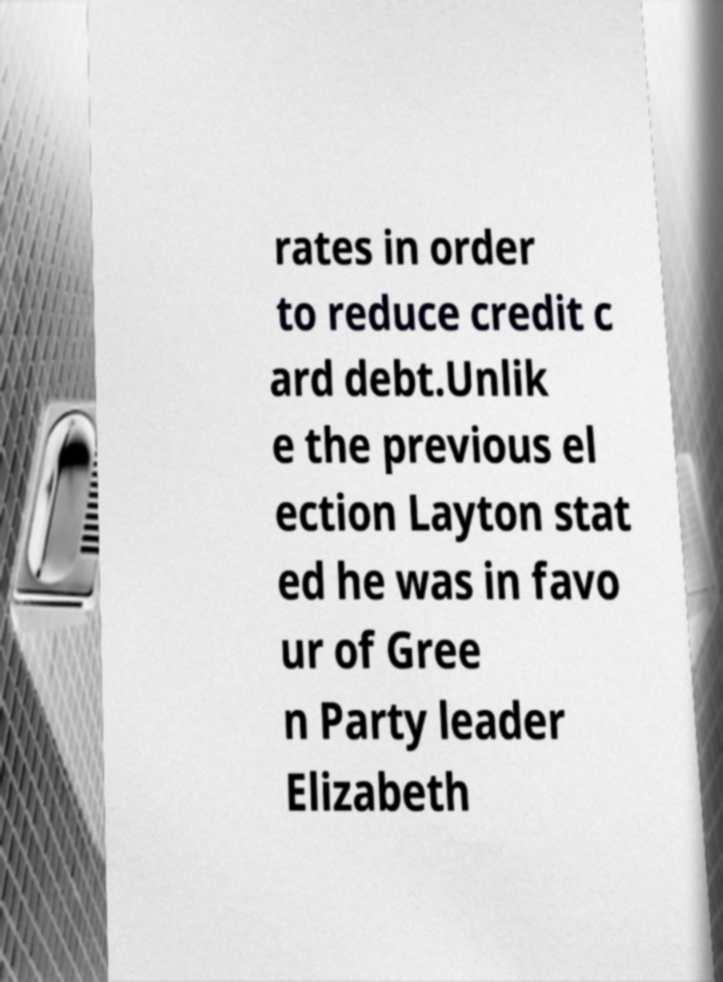What messages or text are displayed in this image? I need them in a readable, typed format. rates in order to reduce credit c ard debt.Unlik e the previous el ection Layton stat ed he was in favo ur of Gree n Party leader Elizabeth 